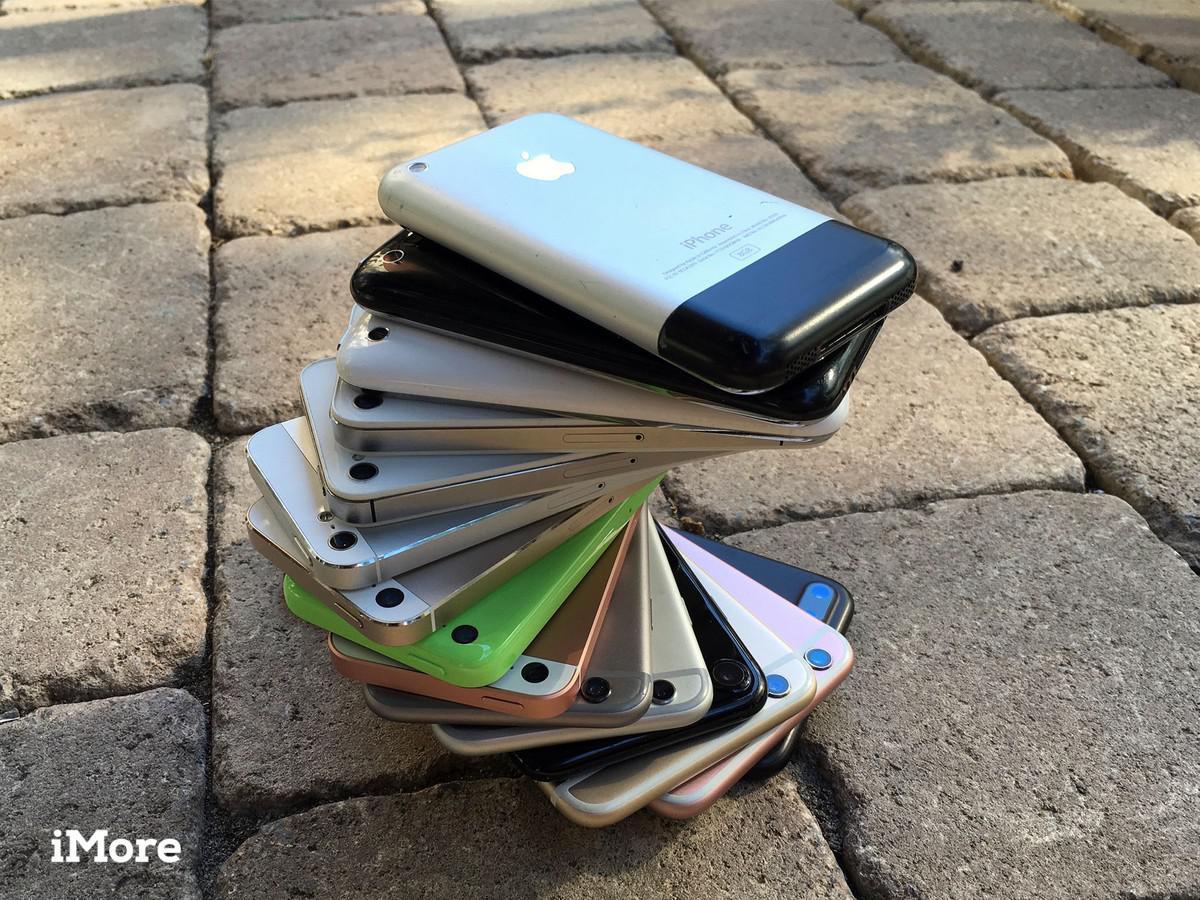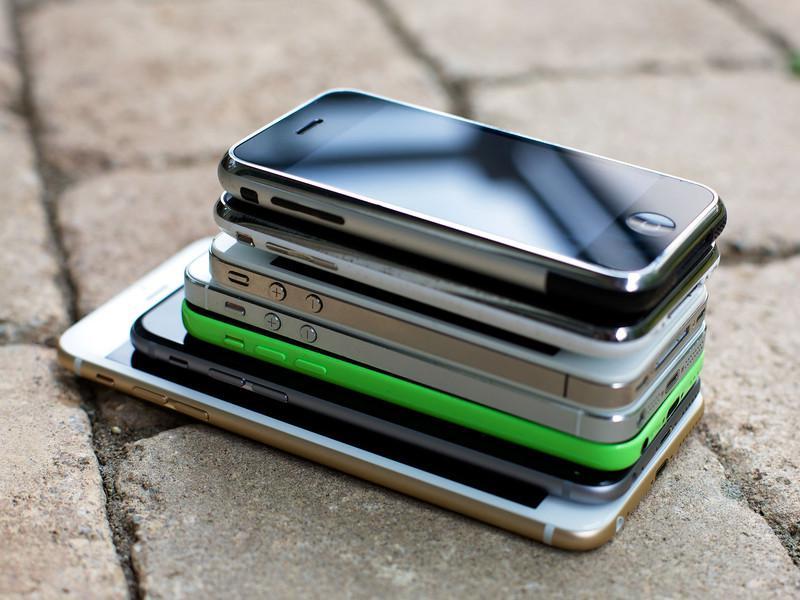The first image is the image on the left, the second image is the image on the right. Analyze the images presented: Is the assertion "There are more phones in the left image than in the right image." valid? Answer yes or no. Yes. The first image is the image on the left, the second image is the image on the right. Considering the images on both sides, is "The phones in each of the image are stacked upon each other." valid? Answer yes or no. Yes. 